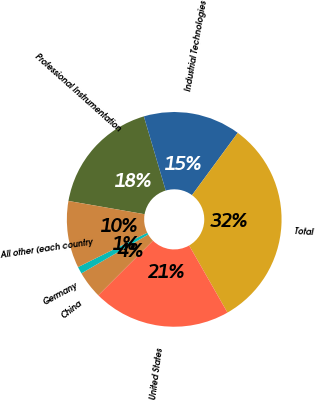<chart> <loc_0><loc_0><loc_500><loc_500><pie_chart><fcel>Professional Instrumentation<fcel>Industrial Technologies<fcel>Total<fcel>United States<fcel>China<fcel>Germany<fcel>All other (each country<nl><fcel>17.7%<fcel>14.64%<fcel>31.66%<fcel>20.76%<fcel>4.12%<fcel>1.06%<fcel>10.07%<nl></chart> 